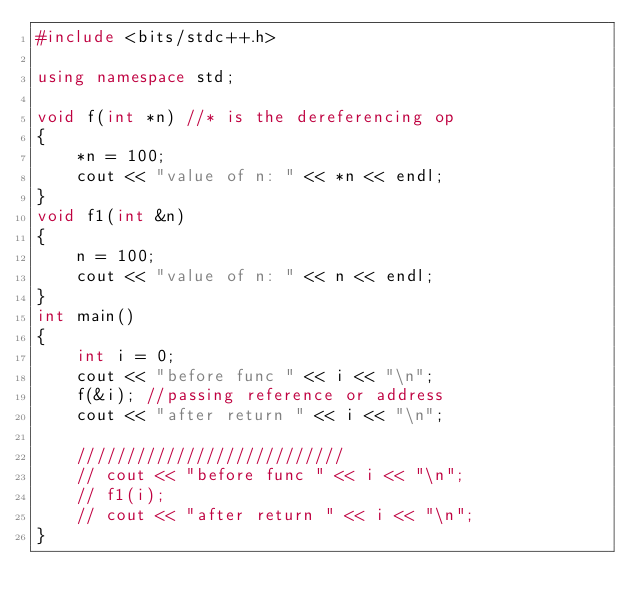Convert code to text. <code><loc_0><loc_0><loc_500><loc_500><_C++_>#include <bits/stdc++.h>

using namespace std;

void f(int *n) //* is the dereferencing op
{
    *n = 100;
    cout << "value of n: " << *n << endl;
}
void f1(int &n)
{
    n = 100;
    cout << "value of n: " << n << endl;
}
int main()
{
    int i = 0;
    cout << "before func " << i << "\n";
    f(&i); //passing reference or address
    cout << "after return " << i << "\n";

    ///////////////////////////
    // cout << "before func " << i << "\n";
    // f1(i);
    // cout << "after return " << i << "\n";
}</code> 